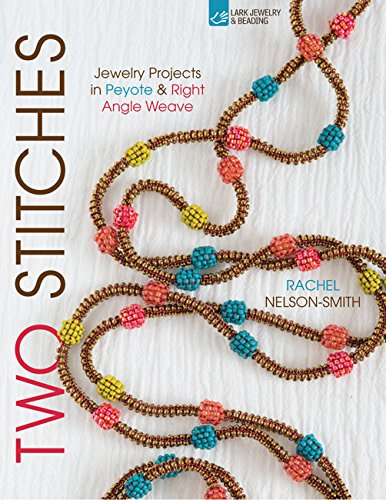Is this book related to History? No, this book does not delve into history; it focuses primarily on contemporary craft practices and jewelry designs using peyote and right angle weave techniques. 